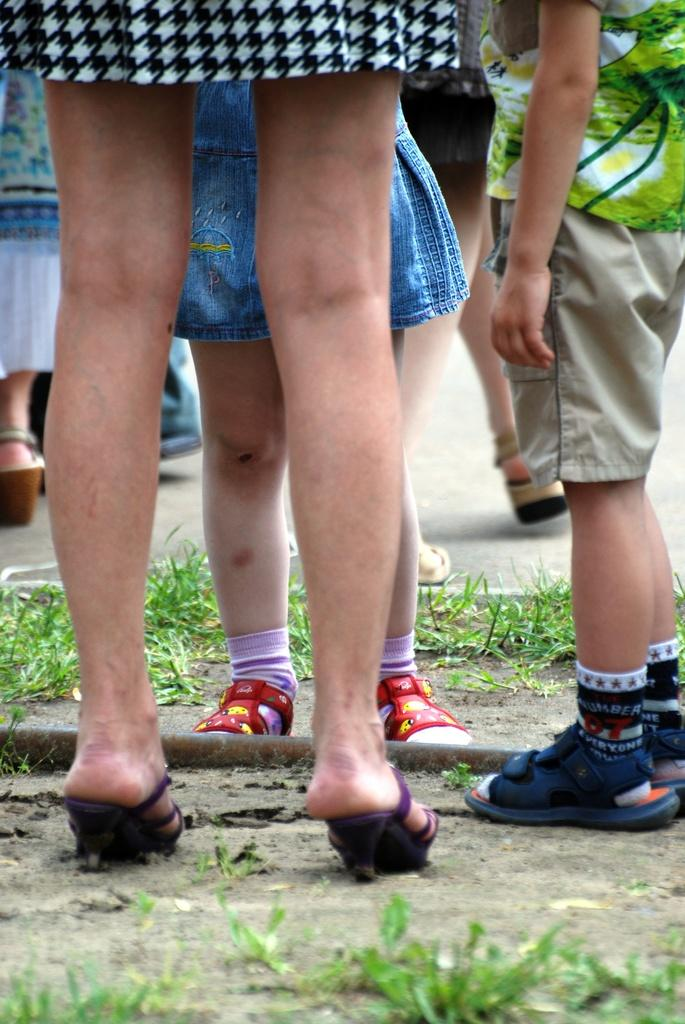Who is present in the image? There are women and kids in the image. What are the women and kids standing on? They are standing on land. What type of vegetation is present on the land? There is grass on the land. What type of trousers is the squirrel wearing in the image? There is no squirrel present in the image, and therefore no trousers to consider. 